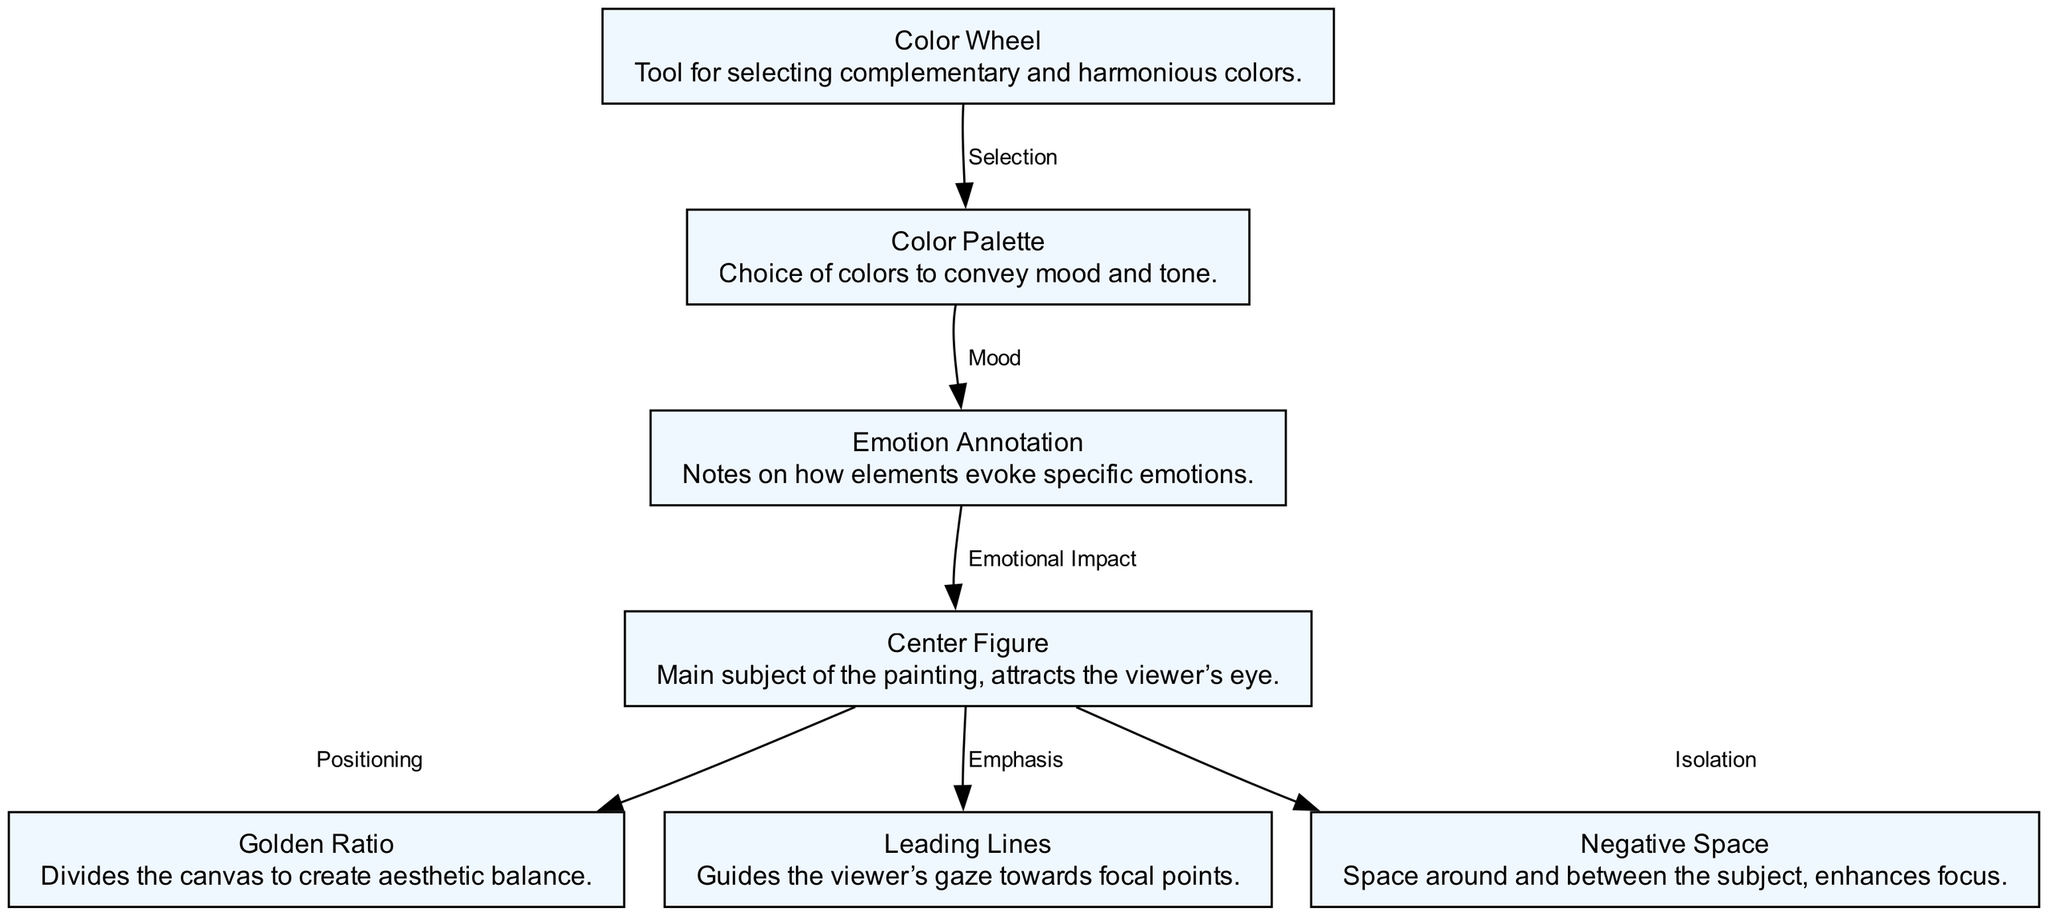What is the main subject labeled in the diagram? The main subject of the painting is identified as "Center Figure," which is explicitly mentioned in the corresponding node within the diagram.
Answer: Center Figure How many nodes are present in the diagram? By counting the individual entries listed in the "nodes" section of the diagram's data, there are seven distinct nodes, each representing different components of painting composition.
Answer: 7 Which node is connected to the "Color Palette"? The "Color Palette" node is connected to the "Emotion Annotation" node via an edge that specifies the relationship between color choices and emotional responses.
Answer: Emotion Annotation What role do "Leading Lines" play in the composition? The diagram indicates that "Leading Lines" serve the purpose of emphasizing the "Center Figure," directing the viewer's gaze towards it, as shown in the edge labeled "Emphasis."
Answer: Emphasis How does the "Negative Space" enhance focus? The relationship noted in the edge leading from "Negative Space" to "Center Figure" indicates that the use of negative space serves to isolate the center figure, making it stand out more prominently in the painting.
Answer: Isolate What is the connection between "Color Wheel" and "Color Palette"? The edge labeled "Selection" illustrates that the "Color Wheel" assists in the process of choosing a harmonious "Color Palette," denoting a supportive relationship between these two nodes.
Answer: Selection In what way does the "Emotion Annotation" affect the "Center Figure"? The diagram describes an edge from "Emotion Annotation" to "Center Figure," indicating that analysis provided in the emotion annotation directly impacts the way the center figure affects viewers emotionally.
Answer: Emotional Impact How does the Golden Ratio affect the placement of the Center Figure? The information in the edge from "Center Figure" to "Golden Ratio" states that the positioning of the center figure follows the Golden Ratio, which aims to create aesthetic balance within the artwork.
Answer: Balance What emotional impact is derived from the "Color Palette"? According to the diagram, the "Color Palette" directly relates to "Emotion Annotation," which conveys that the colors chosen in a palette are influential in evoking specific emotional responses.
Answer: Mood 